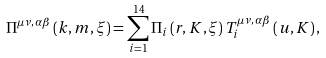Convert formula to latex. <formula><loc_0><loc_0><loc_500><loc_500>\Pi ^ { \mu \nu , \, \alpha \beta } \left ( k , m , \xi \right ) = \sum _ { i = 1 } ^ { 1 4 } \Pi _ { i } \left ( r , K , \xi \right ) T _ { i } ^ { \mu \nu , \, \alpha \beta } \left ( u , K \right ) ,</formula> 